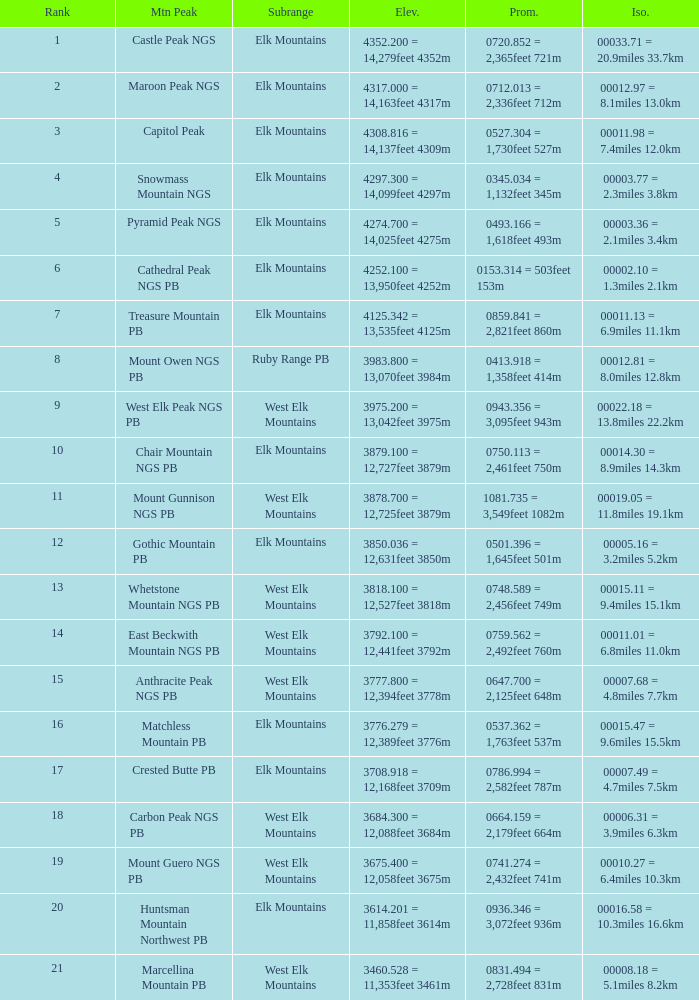Name the Prominence of the Mountain Peak of matchless mountain pb? 0537.362 = 1,763feet 537m. 